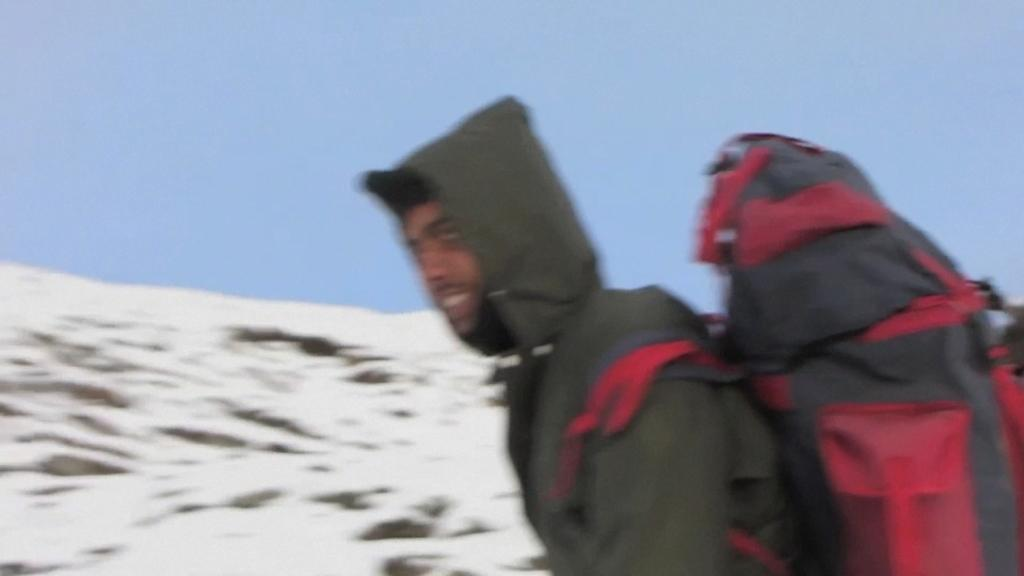Who or what is present in the image? There is a person in the image. What is the person wearing? The person is wearing a jacket. What is the person holding in the image? The person is holding a red and black colored bag. What can be seen in the background of the image? There is snow on the ground and the sky is visible in the background of the image. What type of rhythm is the person dancing to in the image? There is no indication in the image that the person is dancing, nor is there any mention of rhythm. 